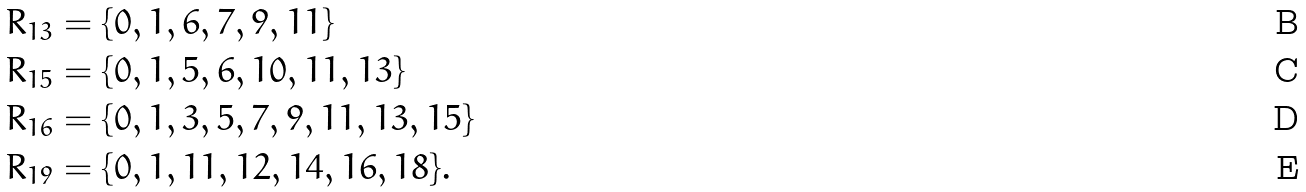Convert formula to latex. <formula><loc_0><loc_0><loc_500><loc_500>R _ { 1 3 } & = \{ 0 , 1 , 6 , 7 , 9 , 1 1 \} \\ R _ { 1 5 } & = \{ 0 , 1 , 5 , 6 , 1 0 , 1 1 , 1 3 \} \\ R _ { 1 6 } & = \{ 0 , 1 , 3 , 5 , 7 , 9 , 1 1 , 1 3 , 1 5 \} \\ R _ { 1 9 } & = \{ 0 , 1 , 1 1 , 1 2 , 1 4 , 1 6 , 1 8 \} .</formula> 